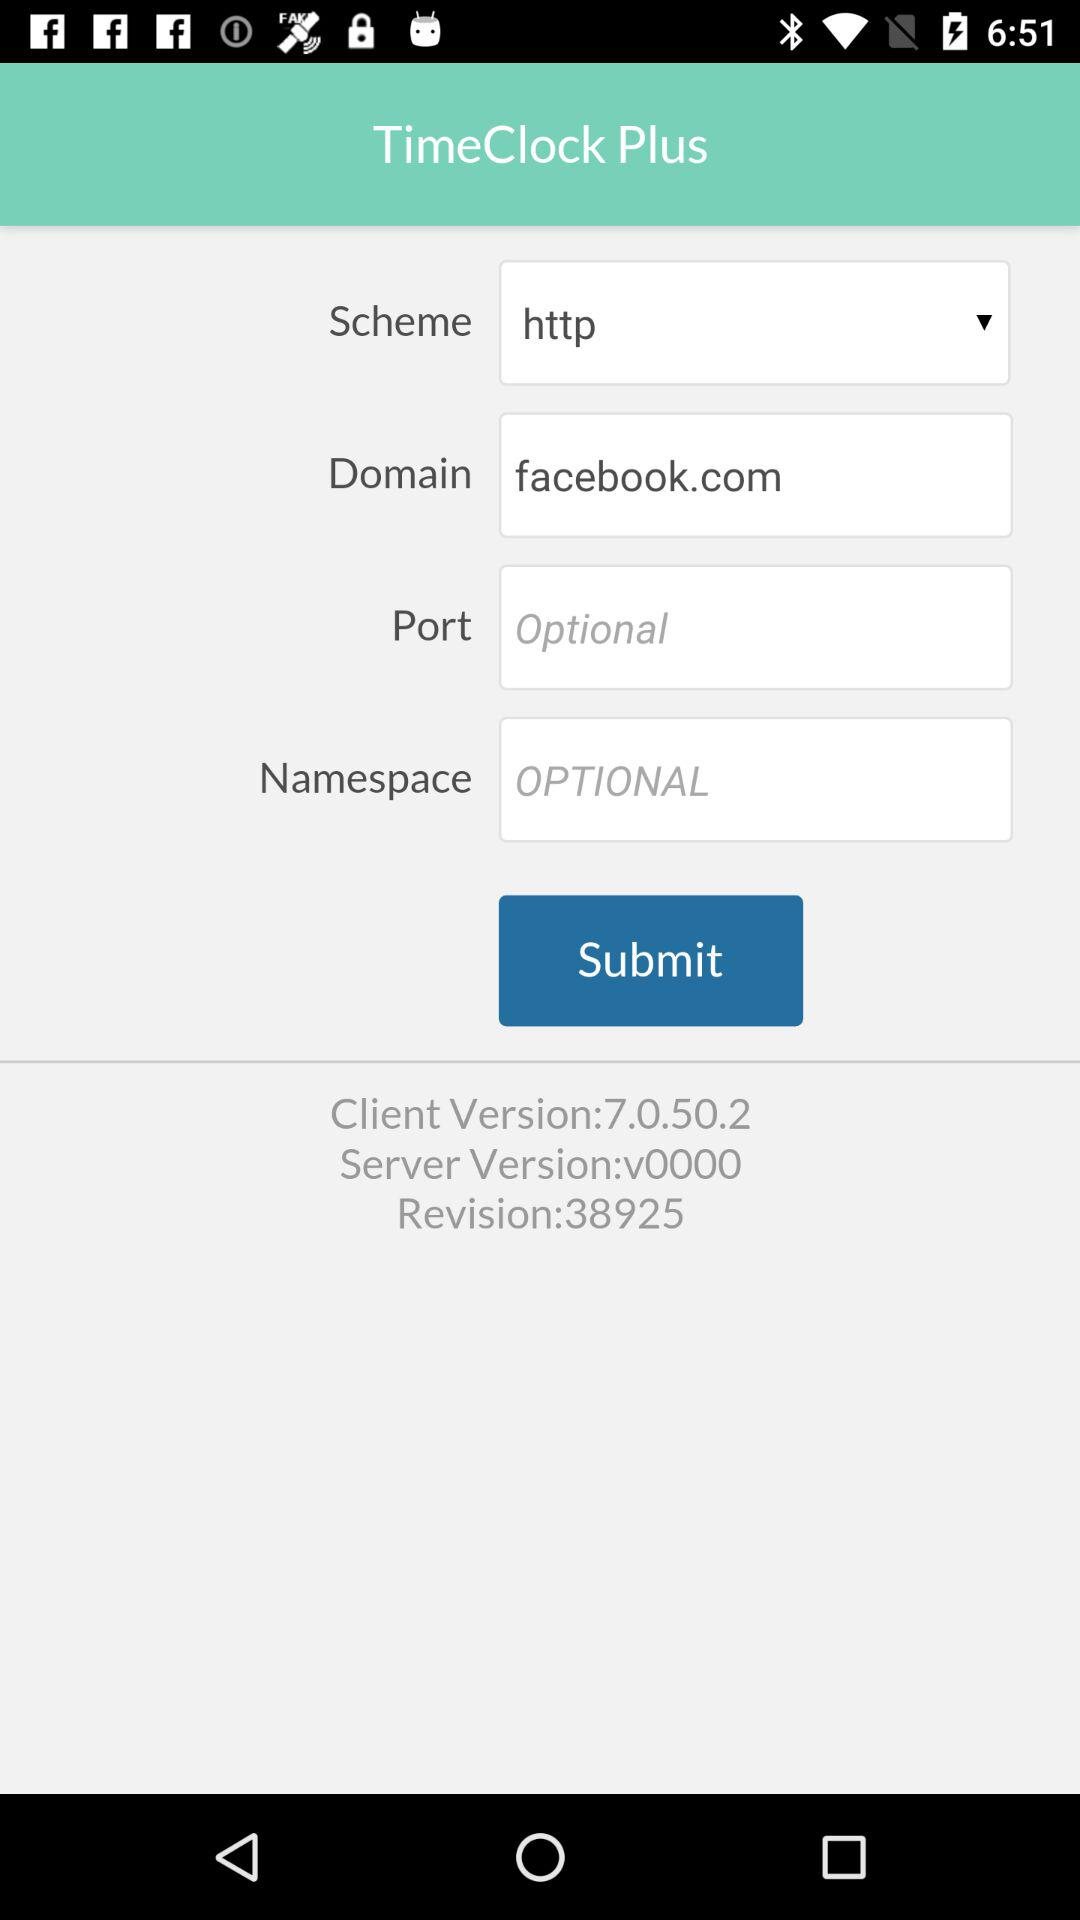What is the scheme? The scheme is http. 